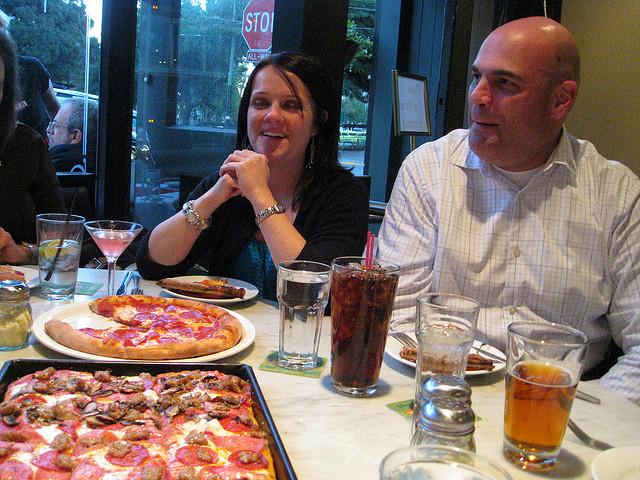Are there straws?
Write a very short answer. Yes. How many pizzas have been taken from the pizza?
Be succinct. 1. Are the people enjoying the pizza?
Write a very short answer. Yes. What is the lady drinking?
Answer briefly. Martini. How many people are in the image?
Be succinct. 5. What are the people drinking?
Quick response, please. Water. Is there more than one person shown?
Keep it brief. Yes. 